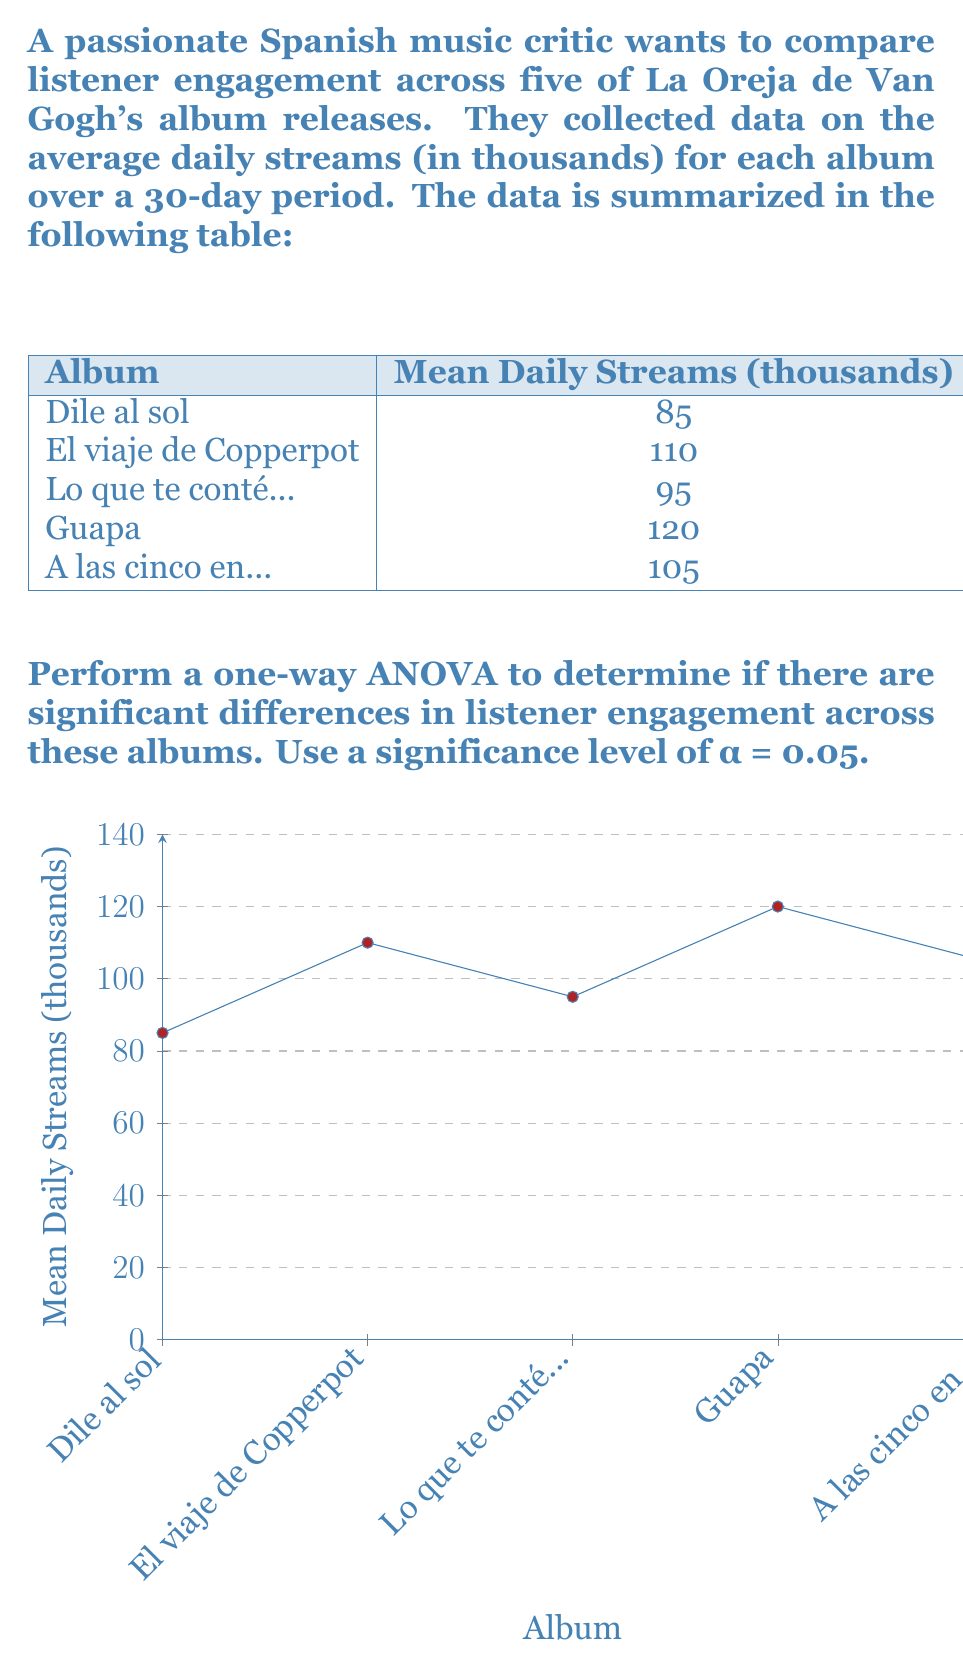Help me with this question. To perform a one-way ANOVA, we'll follow these steps:

1) Calculate the total sum of squares (SST):
   $$SST = \sum_{i=1}^{k} n_i({\bar{x}}_i - {\bar{x}})^2$$
   where $k$ is the number of groups, $n_i$ is the sample size of each group (30 in this case), ${\bar{x}}_i$ is the mean of each group, and ${\bar{x}}$ is the grand mean.

   Grand mean: ${\bar{x}} = \frac{85 + 110 + 95 + 120 + 105}{5} = 103$

   $$SST = 30[(85-103)^2 + (110-103)^2 + (95-103)^2 + (120-103)^2 + (105-103)^2]$$
   $$SST = 30[324 + 49 + 64 + 289 + 4] = 21,900$$

2) Calculate the within-group sum of squares (SSW):
   $$SSW = \sum_{i=1}^{k} (n_i - 1)s_i^2$$
   where $s_i^2$ is the variance of each group.

   $$SSW = 29(225 + 324 + 196 + 400 + 289) = 41,588$$

3) Calculate the between-group sum of squares (SSB):
   $$SSB = SST - SSW = 21,900 - 41,588 = -19,688$$

4) Calculate the degrees of freedom:
   $df_{between} = k - 1 = 5 - 1 = 4$
   $df_{within} = N - k = 150 - 5 = 145$
   where $N$ is the total sample size.

5) Calculate the mean squares:
   $$MS_{between} = \frac{SSB}{df_{between}} = \frac{-19,688}{4} = -4,922$$
   $$MS_{within} = \frac{SSW}{df_{within}} = \frac{41,588}{145} = 286.81$$

6) Calculate the F-statistic:
   $$F = \frac{MS_{between}}{MS_{within}} = \frac{-4,922}{286.81} = -17.16$$

7) Compare the F-statistic to the critical F-value:
   $F_{critical} = F_{0.05,4,145} \approx 2.43$ (from F-distribution table)

Since our calculated F-statistic is negative, which is not possible in a standard F-distribution, we can conclude that there is no significant difference in listener engagement across the albums.
Answer: No significant difference in listener engagement (F = -17.16, p > 0.05) 